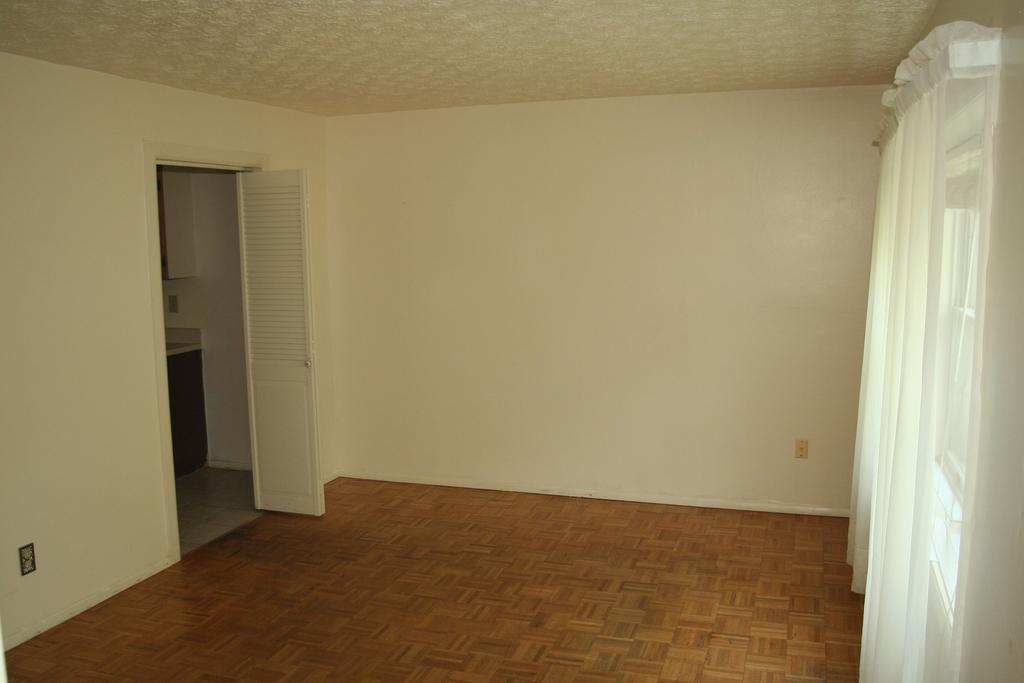How would you summarize this image in a sentence or two? This is a picture of inside of the house in this picture, on the right side there are some windows and curtains and on the left side there is a door. And in the background there is a wall, at the bottom there is a floor and on the top there is ceiling. 